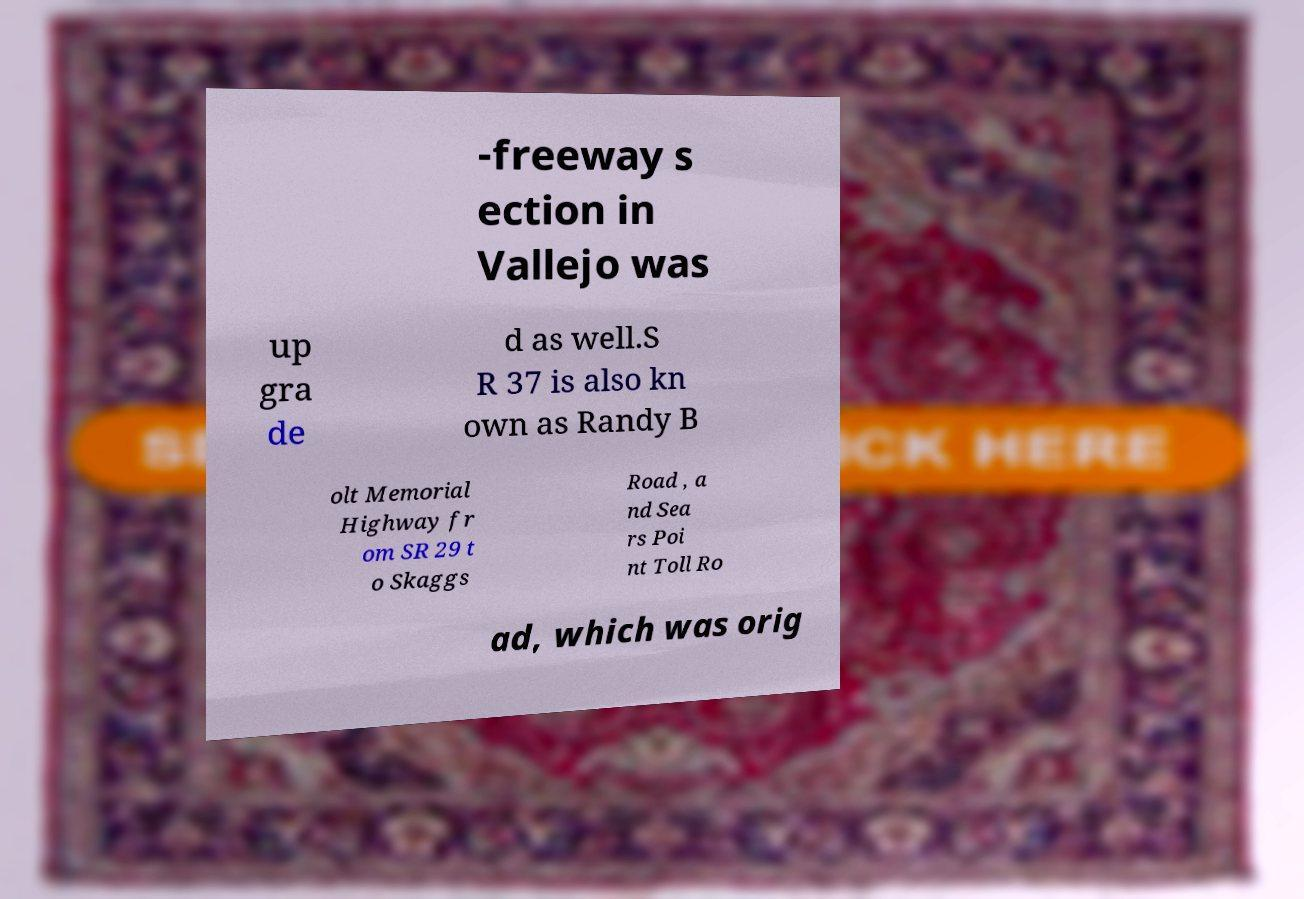What messages or text are displayed in this image? I need them in a readable, typed format. -freeway s ection in Vallejo was up gra de d as well.S R 37 is also kn own as Randy B olt Memorial Highway fr om SR 29 t o Skaggs Road , a nd Sea rs Poi nt Toll Ro ad, which was orig 